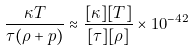Convert formula to latex. <formula><loc_0><loc_0><loc_500><loc_500>\frac { \kappa T } { \tau ( \rho + p ) } \approx \frac { [ \kappa ] [ T ] } { [ \tau ] [ \rho ] } \times 1 0 ^ { - 4 2 }</formula> 